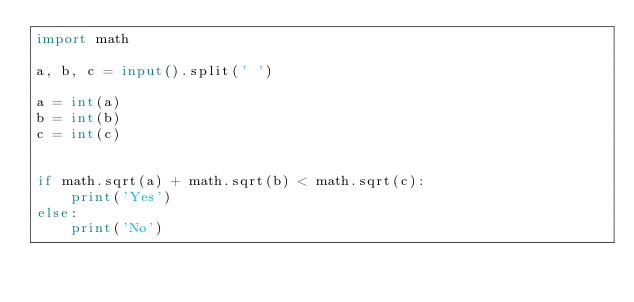Convert code to text. <code><loc_0><loc_0><loc_500><loc_500><_Python_>import math

a, b, c = input().split(' ')

a = int(a)
b = int(b)
c = int(c)


if math.sqrt(a) + math.sqrt(b) < math.sqrt(c):
    print('Yes')
else:
    print('No')</code> 